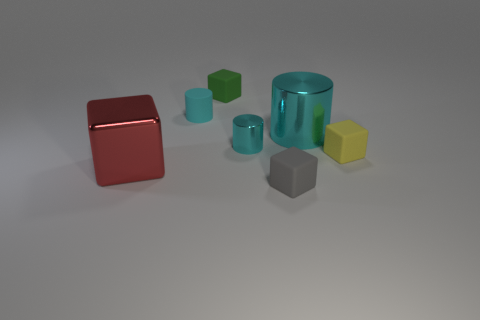What number of other objects are there of the same color as the rubber cylinder?
Your answer should be very brief. 2. How many other objects are the same material as the big red block?
Make the answer very short. 2. Do the green cube and the cyan matte object have the same size?
Make the answer very short. Yes. How many objects are tiny objects in front of the small matte cylinder or green matte blocks?
Offer a terse response. 4. What material is the large thing in front of the small rubber block that is to the right of the tiny gray rubber block made of?
Ensure brevity in your answer.  Metal. Is there a tiny yellow matte thing that has the same shape as the green object?
Keep it short and to the point. Yes. Do the yellow rubber thing and the cyan cylinder in front of the big cylinder have the same size?
Give a very brief answer. Yes. What number of objects are either small things in front of the shiny block or big things that are on the left side of the tiny shiny thing?
Provide a short and direct response. 2. Is the number of small things in front of the red metal cube greater than the number of red cubes?
Provide a succinct answer. No. What number of yellow objects are the same size as the yellow matte cube?
Ensure brevity in your answer.  0. 